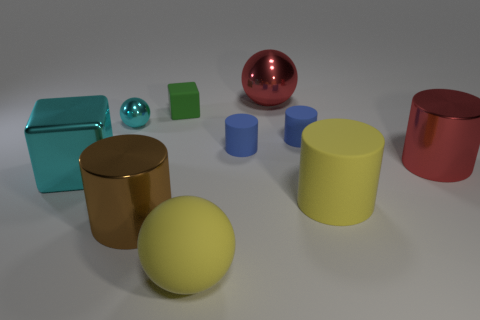How many small things are either gray things or yellow spheres?
Provide a short and direct response. 0. The large brown thing that is the same material as the big red cylinder is what shape?
Offer a terse response. Cylinder. Is the number of small spheres that are to the right of the cyan sphere less than the number of large brown things?
Give a very brief answer. Yes. Do the small cyan shiny thing and the big cyan metal thing have the same shape?
Offer a very short reply. No. How many rubber objects are either brown objects or cyan balls?
Provide a short and direct response. 0. Are there any red blocks that have the same size as the green rubber thing?
Provide a succinct answer. No. What is the shape of the big shiny thing that is the same color as the tiny metal ball?
Your answer should be compact. Cube. How many yellow cylinders are the same size as the matte block?
Offer a very short reply. 0. There is a blue rubber cylinder to the right of the red shiny ball; does it have the same size as the metallic ball to the left of the large yellow matte sphere?
Make the answer very short. Yes. What number of objects are green matte things or metal objects that are in front of the big yellow cylinder?
Offer a terse response. 2. 